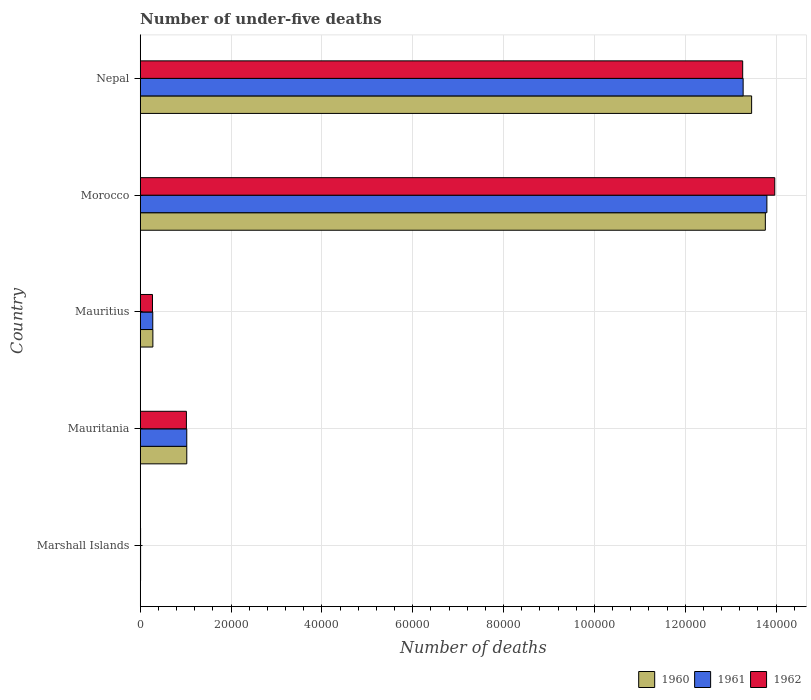How many different coloured bars are there?
Your answer should be compact. 3. How many groups of bars are there?
Offer a very short reply. 5. Are the number of bars on each tick of the Y-axis equal?
Make the answer very short. Yes. What is the label of the 3rd group of bars from the top?
Offer a terse response. Mauritius. In how many cases, is the number of bars for a given country not equal to the number of legend labels?
Provide a short and direct response. 0. Across all countries, what is the maximum number of under-five deaths in 1961?
Keep it short and to the point. 1.38e+05. Across all countries, what is the minimum number of under-five deaths in 1961?
Make the answer very short. 79. In which country was the number of under-five deaths in 1962 maximum?
Your response must be concise. Morocco. In which country was the number of under-five deaths in 1960 minimum?
Offer a very short reply. Marshall Islands. What is the total number of under-five deaths in 1961 in the graph?
Provide a short and direct response. 2.84e+05. What is the difference between the number of under-five deaths in 1962 in Mauritania and that in Morocco?
Offer a terse response. -1.30e+05. What is the difference between the number of under-five deaths in 1960 in Nepal and the number of under-five deaths in 1961 in Mauritius?
Your answer should be very brief. 1.32e+05. What is the average number of under-five deaths in 1960 per country?
Offer a terse response. 5.71e+04. What is the difference between the number of under-five deaths in 1962 and number of under-five deaths in 1960 in Morocco?
Your response must be concise. 2075. In how many countries, is the number of under-five deaths in 1962 greater than 20000 ?
Your answer should be compact. 2. What is the ratio of the number of under-five deaths in 1962 in Mauritius to that in Nepal?
Your answer should be very brief. 0.02. Is the number of under-five deaths in 1962 in Marshall Islands less than that in Morocco?
Your response must be concise. Yes. What is the difference between the highest and the second highest number of under-five deaths in 1960?
Your response must be concise. 3019. What is the difference between the highest and the lowest number of under-five deaths in 1961?
Your response must be concise. 1.38e+05. In how many countries, is the number of under-five deaths in 1962 greater than the average number of under-five deaths in 1962 taken over all countries?
Provide a succinct answer. 2. What does the 3rd bar from the top in Morocco represents?
Keep it short and to the point. 1960. Is it the case that in every country, the sum of the number of under-five deaths in 1961 and number of under-five deaths in 1962 is greater than the number of under-five deaths in 1960?
Give a very brief answer. Yes. How many bars are there?
Your answer should be very brief. 15. Are all the bars in the graph horizontal?
Offer a very short reply. Yes. How many countries are there in the graph?
Make the answer very short. 5. What is the difference between two consecutive major ticks on the X-axis?
Your response must be concise. 2.00e+04. Are the values on the major ticks of X-axis written in scientific E-notation?
Provide a short and direct response. No. Does the graph contain any zero values?
Provide a succinct answer. No. How many legend labels are there?
Make the answer very short. 3. What is the title of the graph?
Your answer should be compact. Number of under-five deaths. What is the label or title of the X-axis?
Make the answer very short. Number of deaths. What is the label or title of the Y-axis?
Give a very brief answer. Country. What is the Number of deaths in 1960 in Marshall Islands?
Make the answer very short. 81. What is the Number of deaths in 1961 in Marshall Islands?
Your answer should be compact. 79. What is the Number of deaths in 1962 in Marshall Islands?
Keep it short and to the point. 78. What is the Number of deaths in 1960 in Mauritania?
Provide a short and direct response. 1.02e+04. What is the Number of deaths of 1961 in Mauritania?
Provide a succinct answer. 1.02e+04. What is the Number of deaths of 1962 in Mauritania?
Your response must be concise. 1.02e+04. What is the Number of deaths in 1960 in Mauritius?
Provide a short and direct response. 2785. What is the Number of deaths of 1961 in Mauritius?
Your response must be concise. 2762. What is the Number of deaths in 1962 in Mauritius?
Give a very brief answer. 2697. What is the Number of deaths of 1960 in Morocco?
Keep it short and to the point. 1.38e+05. What is the Number of deaths in 1961 in Morocco?
Offer a terse response. 1.38e+05. What is the Number of deaths of 1962 in Morocco?
Give a very brief answer. 1.40e+05. What is the Number of deaths of 1960 in Nepal?
Offer a terse response. 1.35e+05. What is the Number of deaths of 1961 in Nepal?
Your answer should be very brief. 1.33e+05. What is the Number of deaths of 1962 in Nepal?
Keep it short and to the point. 1.33e+05. Across all countries, what is the maximum Number of deaths in 1960?
Your response must be concise. 1.38e+05. Across all countries, what is the maximum Number of deaths of 1961?
Offer a very short reply. 1.38e+05. Across all countries, what is the maximum Number of deaths in 1962?
Offer a terse response. 1.40e+05. Across all countries, what is the minimum Number of deaths of 1961?
Your response must be concise. 79. Across all countries, what is the minimum Number of deaths in 1962?
Offer a terse response. 78. What is the total Number of deaths of 1960 in the graph?
Your response must be concise. 2.85e+05. What is the total Number of deaths in 1961 in the graph?
Ensure brevity in your answer.  2.84e+05. What is the total Number of deaths of 1962 in the graph?
Your answer should be compact. 2.85e+05. What is the difference between the Number of deaths in 1960 in Marshall Islands and that in Mauritania?
Keep it short and to the point. -1.02e+04. What is the difference between the Number of deaths of 1961 in Marshall Islands and that in Mauritania?
Provide a short and direct response. -1.02e+04. What is the difference between the Number of deaths in 1962 in Marshall Islands and that in Mauritania?
Ensure brevity in your answer.  -1.01e+04. What is the difference between the Number of deaths of 1960 in Marshall Islands and that in Mauritius?
Offer a terse response. -2704. What is the difference between the Number of deaths of 1961 in Marshall Islands and that in Mauritius?
Give a very brief answer. -2683. What is the difference between the Number of deaths of 1962 in Marshall Islands and that in Mauritius?
Offer a terse response. -2619. What is the difference between the Number of deaths in 1960 in Marshall Islands and that in Morocco?
Your answer should be very brief. -1.38e+05. What is the difference between the Number of deaths in 1961 in Marshall Islands and that in Morocco?
Keep it short and to the point. -1.38e+05. What is the difference between the Number of deaths of 1962 in Marshall Islands and that in Morocco?
Provide a succinct answer. -1.40e+05. What is the difference between the Number of deaths in 1960 in Marshall Islands and that in Nepal?
Your response must be concise. -1.35e+05. What is the difference between the Number of deaths in 1961 in Marshall Islands and that in Nepal?
Your response must be concise. -1.33e+05. What is the difference between the Number of deaths of 1962 in Marshall Islands and that in Nepal?
Make the answer very short. -1.33e+05. What is the difference between the Number of deaths in 1960 in Mauritania and that in Mauritius?
Your response must be concise. 7463. What is the difference between the Number of deaths in 1961 in Mauritania and that in Mauritius?
Give a very brief answer. 7483. What is the difference between the Number of deaths in 1962 in Mauritania and that in Mauritius?
Your answer should be very brief. 7469. What is the difference between the Number of deaths in 1960 in Mauritania and that in Morocco?
Ensure brevity in your answer.  -1.27e+05. What is the difference between the Number of deaths of 1961 in Mauritania and that in Morocco?
Provide a short and direct response. -1.28e+05. What is the difference between the Number of deaths of 1962 in Mauritania and that in Morocco?
Provide a short and direct response. -1.30e+05. What is the difference between the Number of deaths of 1960 in Mauritania and that in Nepal?
Ensure brevity in your answer.  -1.24e+05. What is the difference between the Number of deaths in 1961 in Mauritania and that in Nepal?
Offer a terse response. -1.22e+05. What is the difference between the Number of deaths of 1962 in Mauritania and that in Nepal?
Your answer should be very brief. -1.22e+05. What is the difference between the Number of deaths in 1960 in Mauritius and that in Morocco?
Offer a very short reply. -1.35e+05. What is the difference between the Number of deaths in 1961 in Mauritius and that in Morocco?
Make the answer very short. -1.35e+05. What is the difference between the Number of deaths in 1962 in Mauritius and that in Morocco?
Your answer should be compact. -1.37e+05. What is the difference between the Number of deaths of 1960 in Mauritius and that in Nepal?
Your answer should be compact. -1.32e+05. What is the difference between the Number of deaths in 1961 in Mauritius and that in Nepal?
Ensure brevity in your answer.  -1.30e+05. What is the difference between the Number of deaths in 1962 in Mauritius and that in Nepal?
Ensure brevity in your answer.  -1.30e+05. What is the difference between the Number of deaths of 1960 in Morocco and that in Nepal?
Ensure brevity in your answer.  3019. What is the difference between the Number of deaths of 1961 in Morocco and that in Nepal?
Offer a terse response. 5227. What is the difference between the Number of deaths of 1962 in Morocco and that in Nepal?
Provide a short and direct response. 7061. What is the difference between the Number of deaths of 1960 in Marshall Islands and the Number of deaths of 1961 in Mauritania?
Your answer should be compact. -1.02e+04. What is the difference between the Number of deaths in 1960 in Marshall Islands and the Number of deaths in 1962 in Mauritania?
Offer a terse response. -1.01e+04. What is the difference between the Number of deaths of 1961 in Marshall Islands and the Number of deaths of 1962 in Mauritania?
Provide a short and direct response. -1.01e+04. What is the difference between the Number of deaths in 1960 in Marshall Islands and the Number of deaths in 1961 in Mauritius?
Your response must be concise. -2681. What is the difference between the Number of deaths of 1960 in Marshall Islands and the Number of deaths of 1962 in Mauritius?
Keep it short and to the point. -2616. What is the difference between the Number of deaths in 1961 in Marshall Islands and the Number of deaths in 1962 in Mauritius?
Offer a very short reply. -2618. What is the difference between the Number of deaths in 1960 in Marshall Islands and the Number of deaths in 1961 in Morocco?
Provide a short and direct response. -1.38e+05. What is the difference between the Number of deaths in 1960 in Marshall Islands and the Number of deaths in 1962 in Morocco?
Offer a very short reply. -1.40e+05. What is the difference between the Number of deaths in 1961 in Marshall Islands and the Number of deaths in 1962 in Morocco?
Give a very brief answer. -1.40e+05. What is the difference between the Number of deaths of 1960 in Marshall Islands and the Number of deaths of 1961 in Nepal?
Keep it short and to the point. -1.33e+05. What is the difference between the Number of deaths in 1960 in Marshall Islands and the Number of deaths in 1962 in Nepal?
Keep it short and to the point. -1.33e+05. What is the difference between the Number of deaths in 1961 in Marshall Islands and the Number of deaths in 1962 in Nepal?
Keep it short and to the point. -1.33e+05. What is the difference between the Number of deaths of 1960 in Mauritania and the Number of deaths of 1961 in Mauritius?
Your answer should be very brief. 7486. What is the difference between the Number of deaths in 1960 in Mauritania and the Number of deaths in 1962 in Mauritius?
Your response must be concise. 7551. What is the difference between the Number of deaths in 1961 in Mauritania and the Number of deaths in 1962 in Mauritius?
Provide a short and direct response. 7548. What is the difference between the Number of deaths in 1960 in Mauritania and the Number of deaths in 1961 in Morocco?
Give a very brief answer. -1.28e+05. What is the difference between the Number of deaths in 1960 in Mauritania and the Number of deaths in 1962 in Morocco?
Offer a very short reply. -1.29e+05. What is the difference between the Number of deaths in 1961 in Mauritania and the Number of deaths in 1962 in Morocco?
Your answer should be very brief. -1.29e+05. What is the difference between the Number of deaths in 1960 in Mauritania and the Number of deaths in 1961 in Nepal?
Your response must be concise. -1.22e+05. What is the difference between the Number of deaths in 1960 in Mauritania and the Number of deaths in 1962 in Nepal?
Provide a succinct answer. -1.22e+05. What is the difference between the Number of deaths of 1961 in Mauritania and the Number of deaths of 1962 in Nepal?
Your response must be concise. -1.22e+05. What is the difference between the Number of deaths of 1960 in Mauritius and the Number of deaths of 1961 in Morocco?
Your answer should be very brief. -1.35e+05. What is the difference between the Number of deaths of 1960 in Mauritius and the Number of deaths of 1962 in Morocco?
Ensure brevity in your answer.  -1.37e+05. What is the difference between the Number of deaths of 1961 in Mauritius and the Number of deaths of 1962 in Morocco?
Your response must be concise. -1.37e+05. What is the difference between the Number of deaths of 1960 in Mauritius and the Number of deaths of 1961 in Nepal?
Provide a short and direct response. -1.30e+05. What is the difference between the Number of deaths in 1960 in Mauritius and the Number of deaths in 1962 in Nepal?
Your response must be concise. -1.30e+05. What is the difference between the Number of deaths in 1961 in Mauritius and the Number of deaths in 1962 in Nepal?
Keep it short and to the point. -1.30e+05. What is the difference between the Number of deaths in 1960 in Morocco and the Number of deaths in 1961 in Nepal?
Offer a terse response. 4887. What is the difference between the Number of deaths in 1960 in Morocco and the Number of deaths in 1962 in Nepal?
Offer a very short reply. 4986. What is the difference between the Number of deaths in 1961 in Morocco and the Number of deaths in 1962 in Nepal?
Offer a very short reply. 5326. What is the average Number of deaths of 1960 per country?
Offer a terse response. 5.71e+04. What is the average Number of deaths of 1961 per country?
Offer a terse response. 5.68e+04. What is the average Number of deaths of 1962 per country?
Provide a short and direct response. 5.71e+04. What is the difference between the Number of deaths of 1960 and Number of deaths of 1962 in Marshall Islands?
Keep it short and to the point. 3. What is the difference between the Number of deaths in 1960 and Number of deaths in 1961 in Mauritania?
Ensure brevity in your answer.  3. What is the difference between the Number of deaths of 1960 and Number of deaths of 1962 in Mauritania?
Keep it short and to the point. 82. What is the difference between the Number of deaths in 1961 and Number of deaths in 1962 in Mauritania?
Provide a succinct answer. 79. What is the difference between the Number of deaths of 1960 and Number of deaths of 1962 in Mauritius?
Your answer should be compact. 88. What is the difference between the Number of deaths in 1961 and Number of deaths in 1962 in Mauritius?
Offer a very short reply. 65. What is the difference between the Number of deaths of 1960 and Number of deaths of 1961 in Morocco?
Keep it short and to the point. -340. What is the difference between the Number of deaths in 1960 and Number of deaths in 1962 in Morocco?
Keep it short and to the point. -2075. What is the difference between the Number of deaths of 1961 and Number of deaths of 1962 in Morocco?
Offer a terse response. -1735. What is the difference between the Number of deaths in 1960 and Number of deaths in 1961 in Nepal?
Your response must be concise. 1868. What is the difference between the Number of deaths of 1960 and Number of deaths of 1962 in Nepal?
Keep it short and to the point. 1967. What is the difference between the Number of deaths of 1961 and Number of deaths of 1962 in Nepal?
Offer a terse response. 99. What is the ratio of the Number of deaths of 1960 in Marshall Islands to that in Mauritania?
Offer a very short reply. 0.01. What is the ratio of the Number of deaths in 1961 in Marshall Islands to that in Mauritania?
Your answer should be compact. 0.01. What is the ratio of the Number of deaths in 1962 in Marshall Islands to that in Mauritania?
Provide a succinct answer. 0.01. What is the ratio of the Number of deaths of 1960 in Marshall Islands to that in Mauritius?
Offer a very short reply. 0.03. What is the ratio of the Number of deaths of 1961 in Marshall Islands to that in Mauritius?
Make the answer very short. 0.03. What is the ratio of the Number of deaths of 1962 in Marshall Islands to that in Mauritius?
Your response must be concise. 0.03. What is the ratio of the Number of deaths of 1960 in Marshall Islands to that in Morocco?
Provide a succinct answer. 0. What is the ratio of the Number of deaths of 1961 in Marshall Islands to that in Morocco?
Keep it short and to the point. 0. What is the ratio of the Number of deaths of 1962 in Marshall Islands to that in Morocco?
Provide a succinct answer. 0. What is the ratio of the Number of deaths in 1960 in Marshall Islands to that in Nepal?
Your answer should be very brief. 0. What is the ratio of the Number of deaths of 1961 in Marshall Islands to that in Nepal?
Offer a very short reply. 0. What is the ratio of the Number of deaths of 1962 in Marshall Islands to that in Nepal?
Your answer should be compact. 0. What is the ratio of the Number of deaths in 1960 in Mauritania to that in Mauritius?
Your response must be concise. 3.68. What is the ratio of the Number of deaths in 1961 in Mauritania to that in Mauritius?
Your response must be concise. 3.71. What is the ratio of the Number of deaths of 1962 in Mauritania to that in Mauritius?
Keep it short and to the point. 3.77. What is the ratio of the Number of deaths in 1960 in Mauritania to that in Morocco?
Your answer should be very brief. 0.07. What is the ratio of the Number of deaths in 1961 in Mauritania to that in Morocco?
Ensure brevity in your answer.  0.07. What is the ratio of the Number of deaths of 1962 in Mauritania to that in Morocco?
Ensure brevity in your answer.  0.07. What is the ratio of the Number of deaths in 1960 in Mauritania to that in Nepal?
Your answer should be compact. 0.08. What is the ratio of the Number of deaths in 1961 in Mauritania to that in Nepal?
Make the answer very short. 0.08. What is the ratio of the Number of deaths in 1962 in Mauritania to that in Nepal?
Make the answer very short. 0.08. What is the ratio of the Number of deaths of 1960 in Mauritius to that in Morocco?
Provide a short and direct response. 0.02. What is the ratio of the Number of deaths in 1962 in Mauritius to that in Morocco?
Provide a short and direct response. 0.02. What is the ratio of the Number of deaths of 1960 in Mauritius to that in Nepal?
Give a very brief answer. 0.02. What is the ratio of the Number of deaths of 1961 in Mauritius to that in Nepal?
Provide a short and direct response. 0.02. What is the ratio of the Number of deaths in 1962 in Mauritius to that in Nepal?
Give a very brief answer. 0.02. What is the ratio of the Number of deaths of 1960 in Morocco to that in Nepal?
Make the answer very short. 1.02. What is the ratio of the Number of deaths of 1961 in Morocco to that in Nepal?
Provide a short and direct response. 1.04. What is the ratio of the Number of deaths of 1962 in Morocco to that in Nepal?
Offer a terse response. 1.05. What is the difference between the highest and the second highest Number of deaths of 1960?
Make the answer very short. 3019. What is the difference between the highest and the second highest Number of deaths in 1961?
Provide a succinct answer. 5227. What is the difference between the highest and the second highest Number of deaths in 1962?
Your response must be concise. 7061. What is the difference between the highest and the lowest Number of deaths in 1960?
Provide a succinct answer. 1.38e+05. What is the difference between the highest and the lowest Number of deaths in 1961?
Provide a succinct answer. 1.38e+05. What is the difference between the highest and the lowest Number of deaths in 1962?
Offer a very short reply. 1.40e+05. 